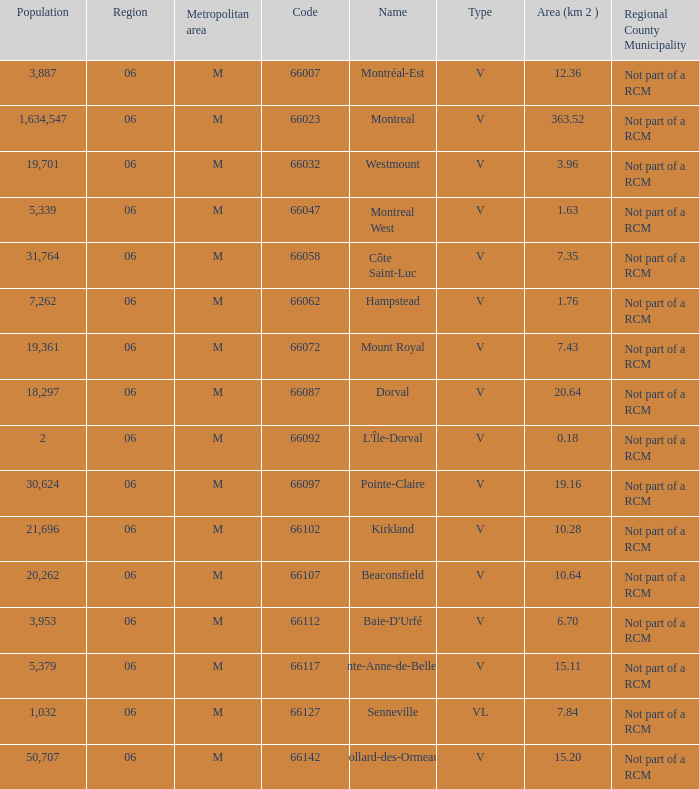Would you be able to parse every entry in this table? {'header': ['Population', 'Region', 'Metropolitan area', 'Code', 'Name', 'Type', 'Area (km 2 )', 'Regional County Municipality'], 'rows': [['3,887', '06', 'M', '66007', 'Montréal-Est', 'V', '12.36', 'Not part of a RCM'], ['1,634,547', '06', 'M', '66023', 'Montreal', 'V', '363.52', 'Not part of a RCM'], ['19,701', '06', 'M', '66032', 'Westmount', 'V', '3.96', 'Not part of a RCM'], ['5,339', '06', 'M', '66047', 'Montreal West', 'V', '1.63', 'Not part of a RCM'], ['31,764', '06', 'M', '66058', 'Côte Saint-Luc', 'V', '7.35', 'Not part of a RCM'], ['7,262', '06', 'M', '66062', 'Hampstead', 'V', '1.76', 'Not part of a RCM'], ['19,361', '06', 'M', '66072', 'Mount Royal', 'V', '7.43', 'Not part of a RCM'], ['18,297', '06', 'M', '66087', 'Dorval', 'V', '20.64', 'Not part of a RCM'], ['2', '06', 'M', '66092', "L'Île-Dorval", 'V', '0.18', 'Not part of a RCM'], ['30,624', '06', 'M', '66097', 'Pointe-Claire', 'V', '19.16', 'Not part of a RCM'], ['21,696', '06', 'M', '66102', 'Kirkland', 'V', '10.28', 'Not part of a RCM'], ['20,262', '06', 'M', '66107', 'Beaconsfield', 'V', '10.64', 'Not part of a RCM'], ['3,953', '06', 'M', '66112', "Baie-D'Urfé", 'V', '6.70', 'Not part of a RCM'], ['5,379', '06', 'M', '66117', 'Sainte-Anne-de-Bellevue', 'V', '15.11', 'Not part of a RCM'], ['1,032', '06', 'M', '66127', 'Senneville', 'VL', '7.84', 'Not part of a RCM'], ['50,707', '06', 'M', '66142', 'Dollard-des-Ormeaux', 'V', '15.20', 'Not part of a RCM']]} What is the largest area with a Code of 66097, and a Region larger than 6? None. 